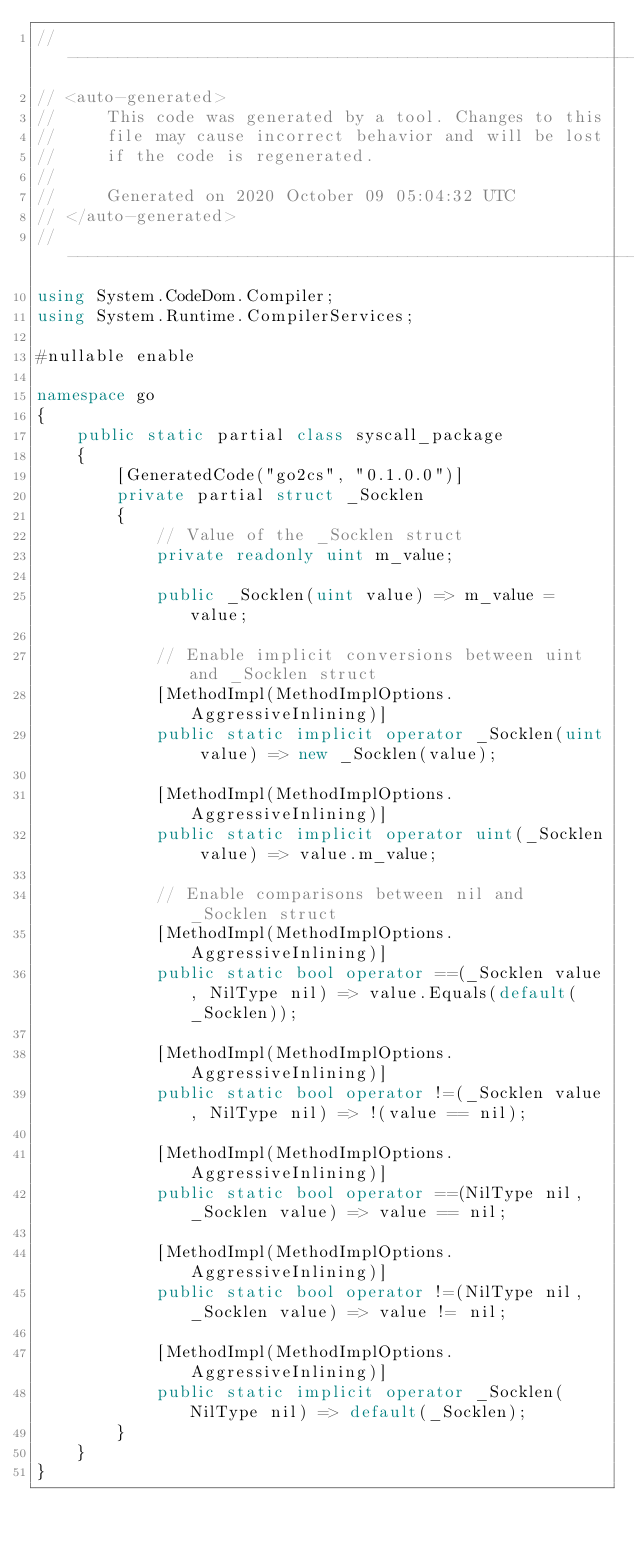<code> <loc_0><loc_0><loc_500><loc_500><_C#_>//---------------------------------------------------------
// <auto-generated>
//     This code was generated by a tool. Changes to this
//     file may cause incorrect behavior and will be lost
//     if the code is regenerated.
//
//     Generated on 2020 October 09 05:04:32 UTC
// </auto-generated>
//---------------------------------------------------------
using System.CodeDom.Compiler;
using System.Runtime.CompilerServices;

#nullable enable

namespace go
{
    public static partial class syscall_package
    {
        [GeneratedCode("go2cs", "0.1.0.0")]
        private partial struct _Socklen
        {
            // Value of the _Socklen struct
            private readonly uint m_value;

            public _Socklen(uint value) => m_value = value;

            // Enable implicit conversions between uint and _Socklen struct
            [MethodImpl(MethodImplOptions.AggressiveInlining)]
            public static implicit operator _Socklen(uint value) => new _Socklen(value);
            
            [MethodImpl(MethodImplOptions.AggressiveInlining)]
            public static implicit operator uint(_Socklen value) => value.m_value;
            
            // Enable comparisons between nil and _Socklen struct
            [MethodImpl(MethodImplOptions.AggressiveInlining)]
            public static bool operator ==(_Socklen value, NilType nil) => value.Equals(default(_Socklen));

            [MethodImpl(MethodImplOptions.AggressiveInlining)]
            public static bool operator !=(_Socklen value, NilType nil) => !(value == nil);

            [MethodImpl(MethodImplOptions.AggressiveInlining)]
            public static bool operator ==(NilType nil, _Socklen value) => value == nil;

            [MethodImpl(MethodImplOptions.AggressiveInlining)]
            public static bool operator !=(NilType nil, _Socklen value) => value != nil;

            [MethodImpl(MethodImplOptions.AggressiveInlining)]
            public static implicit operator _Socklen(NilType nil) => default(_Socklen);
        }
    }
}
</code> 